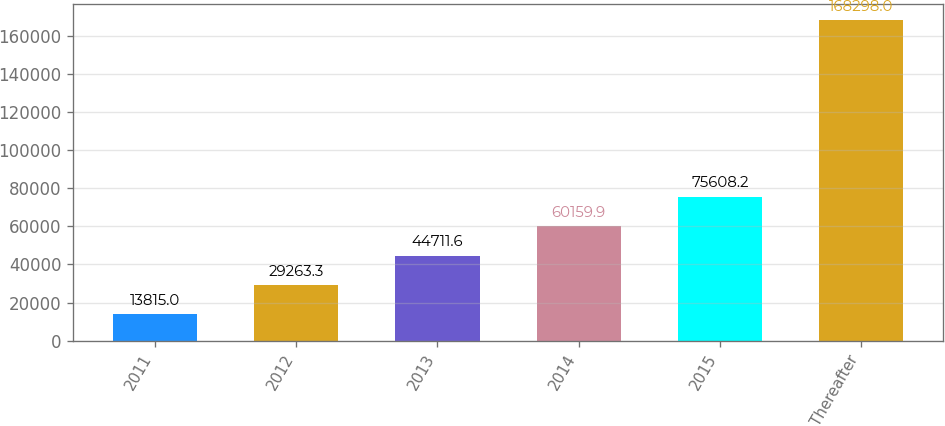Convert chart. <chart><loc_0><loc_0><loc_500><loc_500><bar_chart><fcel>2011<fcel>2012<fcel>2013<fcel>2014<fcel>2015<fcel>Thereafter<nl><fcel>13815<fcel>29263.3<fcel>44711.6<fcel>60159.9<fcel>75608.2<fcel>168298<nl></chart> 